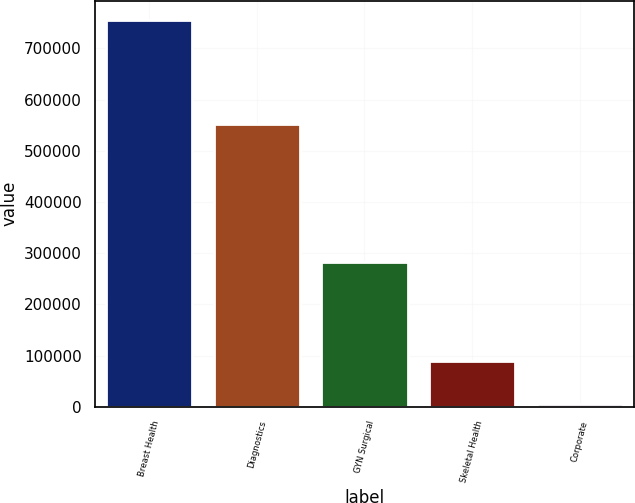<chart> <loc_0><loc_0><loc_500><loc_500><bar_chart><fcel>Breast Health<fcel>Diagnostics<fcel>GYN Surgical<fcel>Skeletal Health<fcel>Corporate<nl><fcel>755542<fcel>552501<fcel>283142<fcel>88367<fcel>4737<nl></chart> 